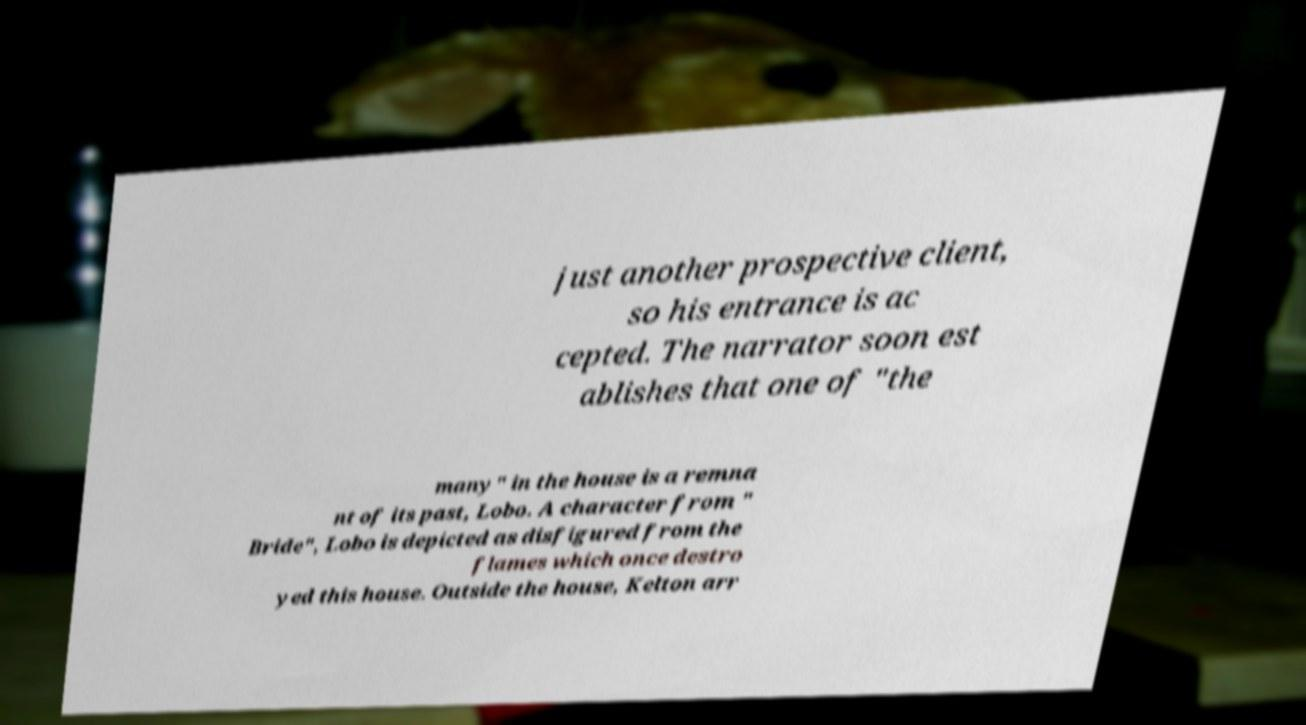There's text embedded in this image that I need extracted. Can you transcribe it verbatim? just another prospective client, so his entrance is ac cepted. The narrator soon est ablishes that one of "the many" in the house is a remna nt of its past, Lobo. A character from " Bride", Lobo is depicted as disfigured from the flames which once destro yed this house. Outside the house, Kelton arr 